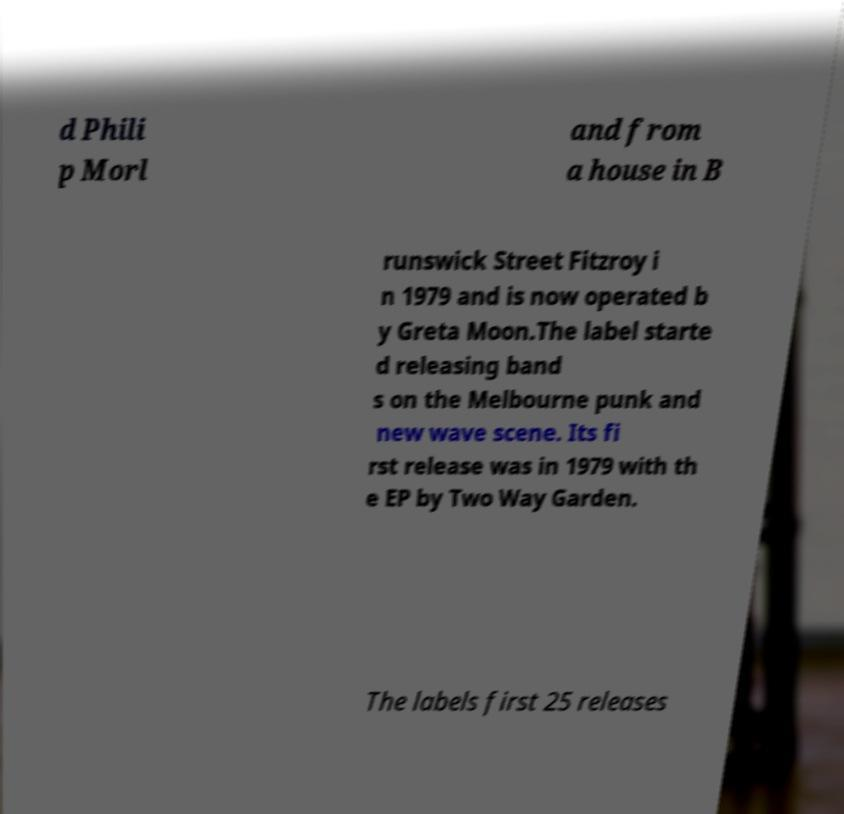There's text embedded in this image that I need extracted. Can you transcribe it verbatim? d Phili p Morl and from a house in B runswick Street Fitzroy i n 1979 and is now operated b y Greta Moon.The label starte d releasing band s on the Melbourne punk and new wave scene. Its fi rst release was in 1979 with th e EP by Two Way Garden. The labels first 25 releases 